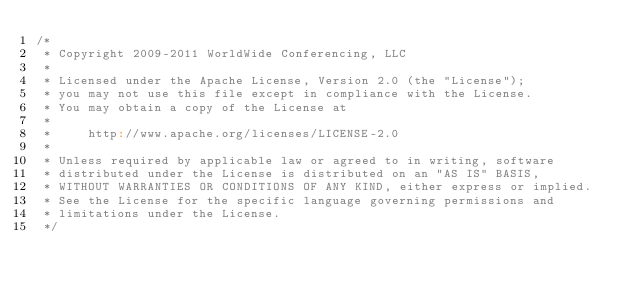Convert code to text. <code><loc_0><loc_0><loc_500><loc_500><_Scala_>/*
 * Copyright 2009-2011 WorldWide Conferencing, LLC
 *
 * Licensed under the Apache License, Version 2.0 (the "License");
 * you may not use this file except in compliance with the License.
 * You may obtain a copy of the License at
 *
 *     http://www.apache.org/licenses/LICENSE-2.0
 *
 * Unless required by applicable law or agreed to in writing, software
 * distributed under the License is distributed on an "AS IS" BASIS,
 * WITHOUT WARRANTIES OR CONDITIONS OF ANY KIND, either express or implied.
 * See the License for the specific language governing permissions and
 * limitations under the License.
 */
</code> 